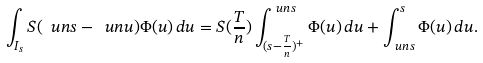Convert formula to latex. <formula><loc_0><loc_0><loc_500><loc_500>\int _ { I _ { s } } S ( \ u n { s } - \ u n { u } ) \Phi ( u ) \, d u & = S ( \frac { T } { n } ) \int _ { ( s - \frac { T } { n } ) ^ { + } } ^ { \ u n { s } } \Phi ( u ) \, d u + \int _ { \ u n { s } } ^ { s } \Phi ( u ) \, d u .</formula> 